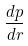Convert formula to latex. <formula><loc_0><loc_0><loc_500><loc_500>\frac { d p } { d r }</formula> 